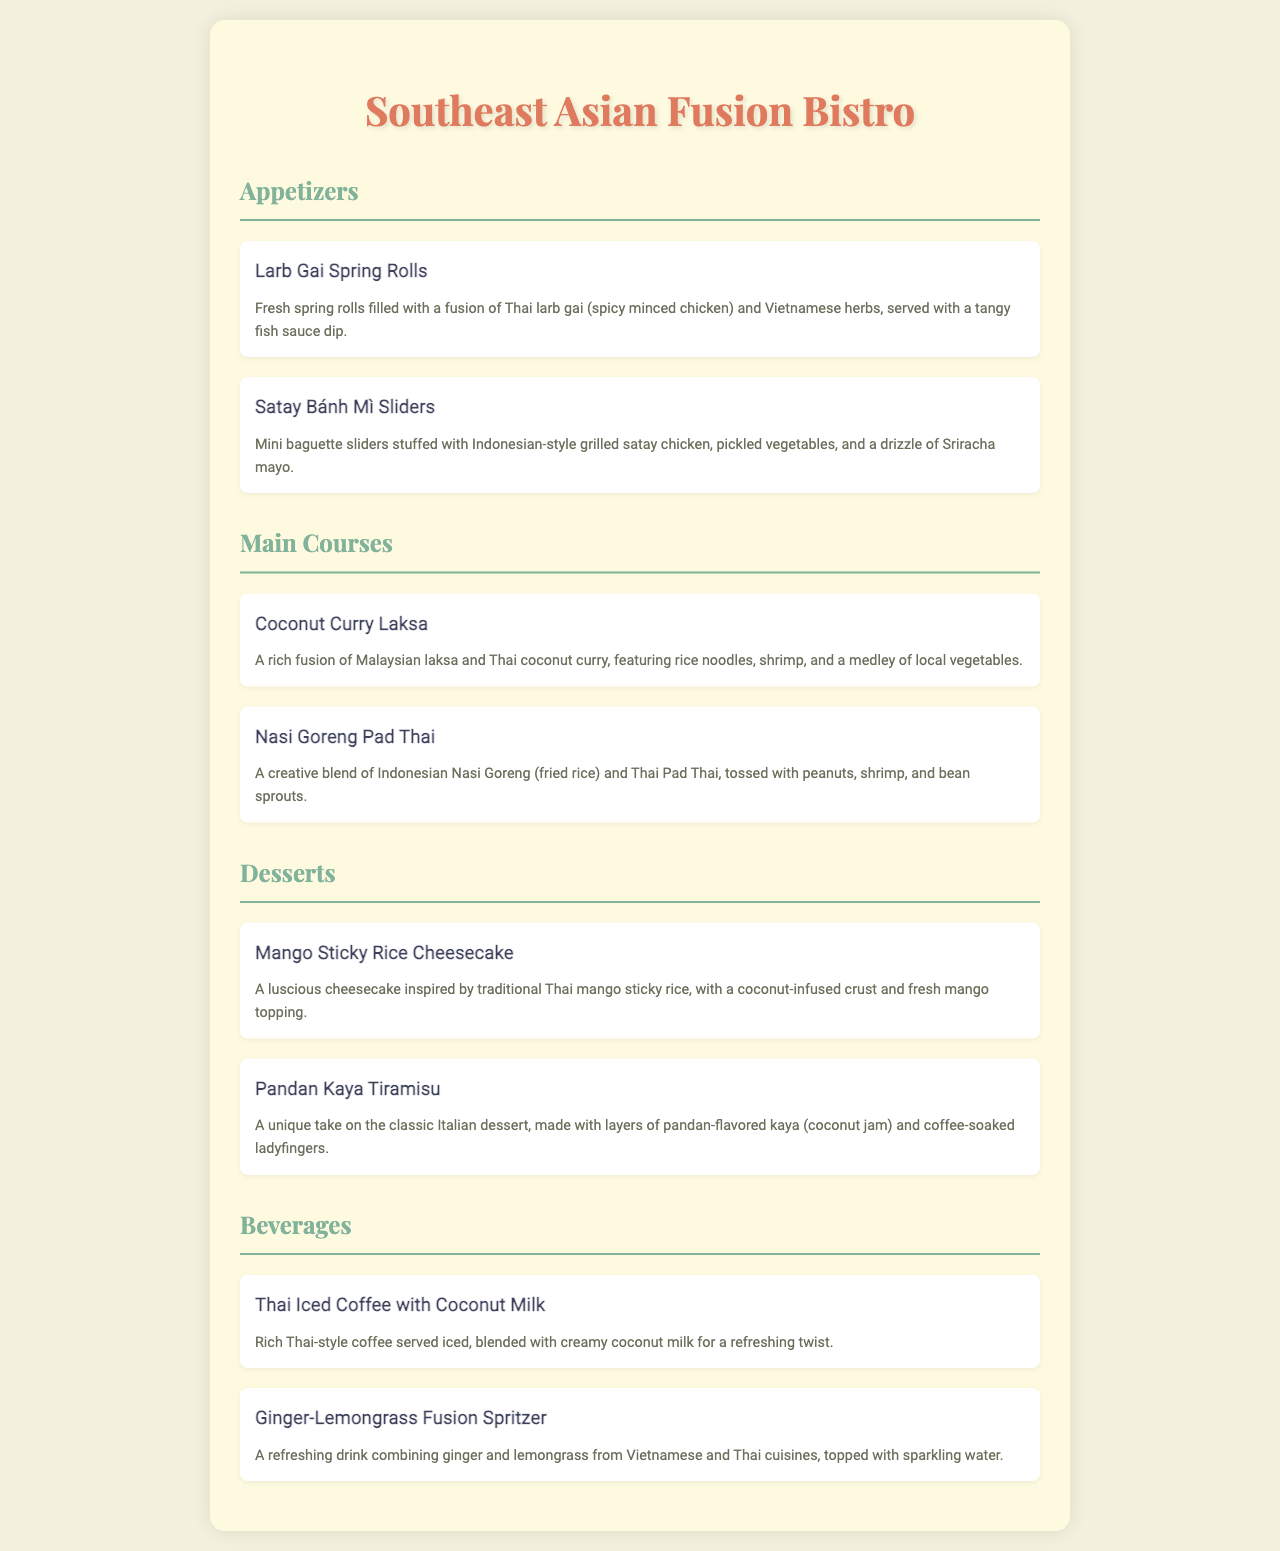What are the appetizers listed in the menu? The appetizers include Larb Gai Spring Rolls and Satay Bánh Mì Sliders.
Answer: Larb Gai Spring Rolls, Satay Bánh Mì Sliders What is the first dessert mentioned? The first dessert in the menu is Mango Sticky Rice Cheesecake.
Answer: Mango Sticky Rice Cheesecake How many main courses are there on the menu? There are two main courses listed in the menu, which are Coconut Curry Laksa and Nasi Goreng Pad Thai.
Answer: Two What unique ingredient is used in the Pandan Kaya Tiramisu? The unique ingredient in the Pandan Kaya Tiramisu is pandan-flavored kaya (coconut jam).
Answer: Pandan-flavored kaya Which beverage combines ginger and lemongrass? The beverage combining ginger and lemongrass is called Ginger-Lemongrass Fusion Spritzer.
Answer: Ginger-Lemongrass Fusion Spritzer What cuisine does the Coconut Curry Laksa originate from? The Coconut Curry Laksa originates from Malaysian cuisine.
Answer: Malaysian Which item features a mix of Thai and Vietnamese flavors? The item featuring a mix of Thai and Vietnamese flavors is Larb Gai Spring Rolls.
Answer: Larb Gai Spring Rolls What is the main feature of the Nasi Goreng Pad Thai dish? The main feature is a blend of Indonesian Nasi Goreng and Thai Pad Thai.
Answer: A blend of Indonesian Nasi Goreng and Thai Pad Thai 